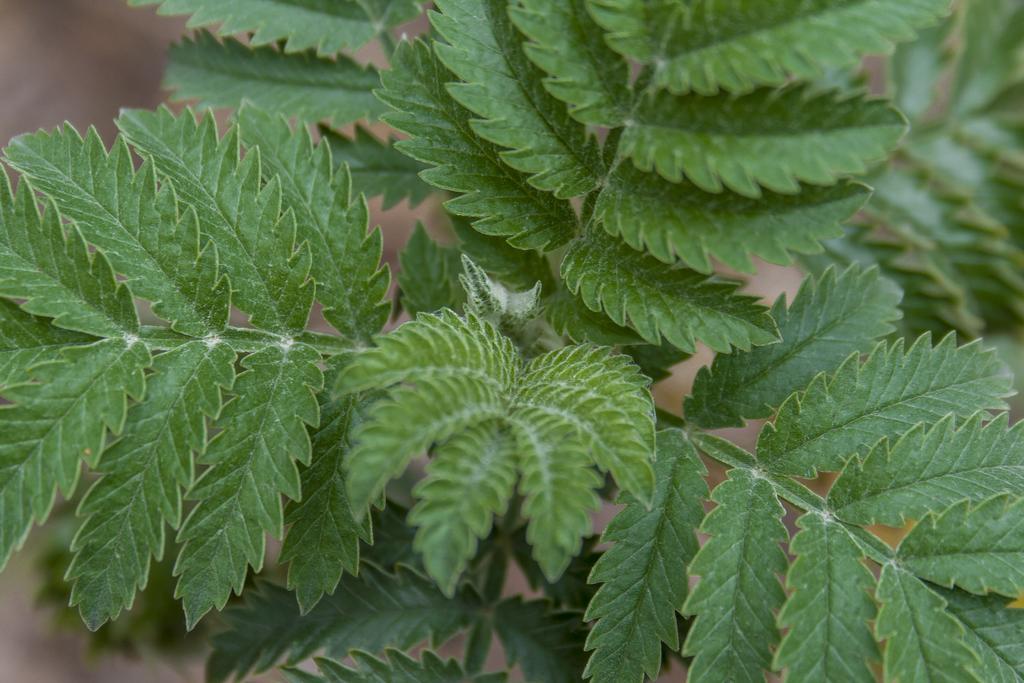Please provide a concise description of this image. In this image we can see a plant with leaves. In the background it is blur. 